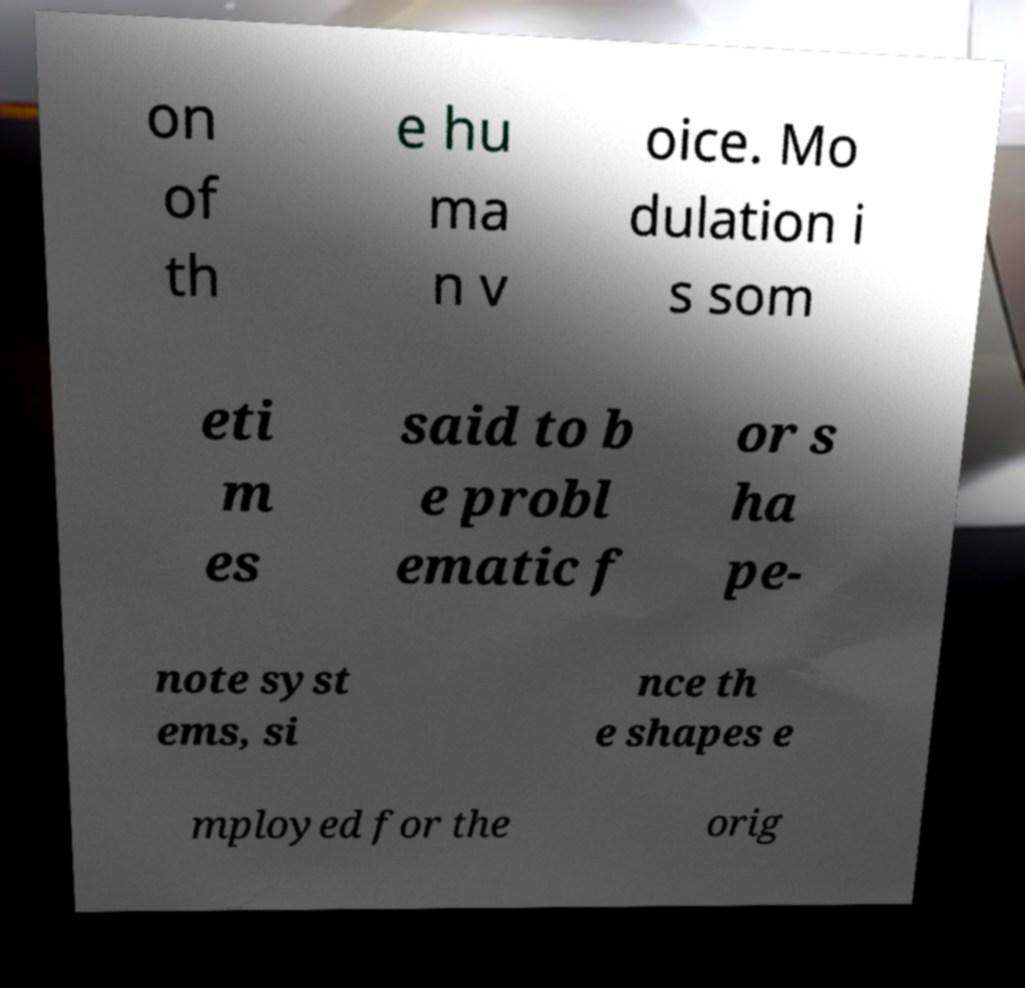Can you accurately transcribe the text from the provided image for me? on of th e hu ma n v oice. Mo dulation i s som eti m es said to b e probl ematic f or s ha pe- note syst ems, si nce th e shapes e mployed for the orig 